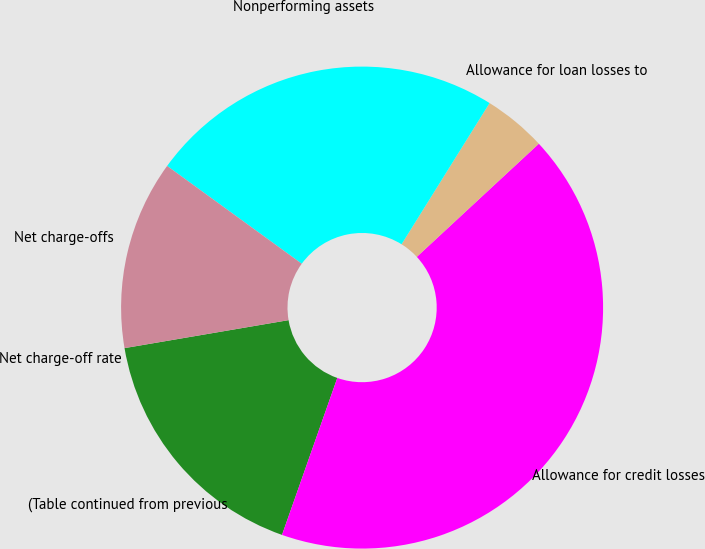Convert chart. <chart><loc_0><loc_0><loc_500><loc_500><pie_chart><fcel>(Table continued from previous<fcel>Allowance for credit losses<fcel>Allowance for loan losses to<fcel>Nonperforming assets<fcel>Net charge-offs<fcel>Net charge-off rate<nl><fcel>16.92%<fcel>42.29%<fcel>4.23%<fcel>23.87%<fcel>12.69%<fcel>0.0%<nl></chart> 